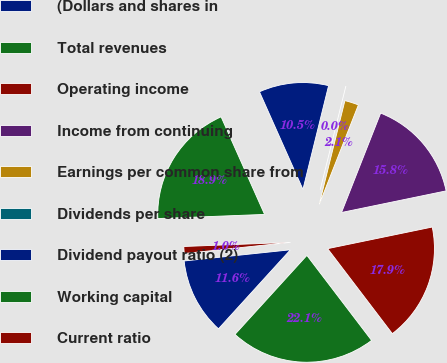Convert chart. <chart><loc_0><loc_0><loc_500><loc_500><pie_chart><fcel>(Dollars and shares in<fcel>Total revenues<fcel>Operating income<fcel>Income from continuing<fcel>Earnings per common share from<fcel>Dividends per share<fcel>Dividend payout ratio (2)<fcel>Working capital<fcel>Current ratio<nl><fcel>11.58%<fcel>22.11%<fcel>17.89%<fcel>15.79%<fcel>2.11%<fcel>0.0%<fcel>10.53%<fcel>18.95%<fcel>1.05%<nl></chart> 